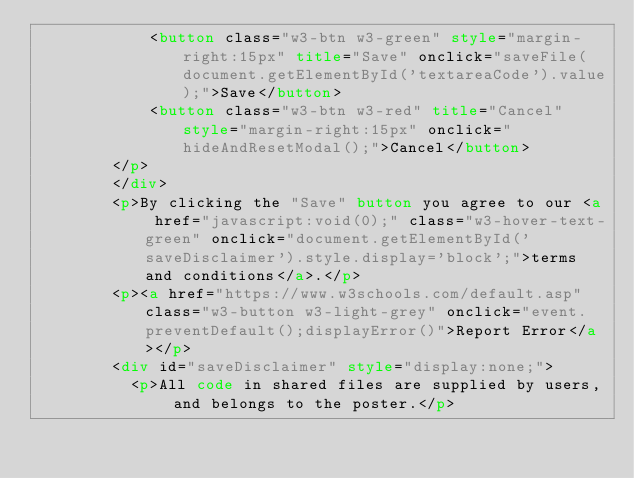<code> <loc_0><loc_0><loc_500><loc_500><_HTML_>            <button class="w3-btn w3-green" style="margin-right:15px" title="Save" onclick="saveFile(document.getElementById('textareaCode').value);">Save</button>
            <button class="w3-btn w3-red" title="Cancel" style="margin-right:15px" onclick="hideAndResetModal();">Cancel</button>
        </p>
        </div>
        <p>By clicking the "Save" button you agree to our <a href="javascript:void(0);" class="w3-hover-text-green" onclick="document.getElementById('saveDisclaimer').style.display='block';">terms and conditions</a>.</p>
        <p><a href="https://www.w3schools.com/default.asp" class="w3-button w3-light-grey" onclick="event.preventDefault();displayError()">Report Error</a></p>
        <div id="saveDisclaimer" style="display:none;">
          <p>All code in shared files are supplied by users, and belongs to the poster.</p></code> 